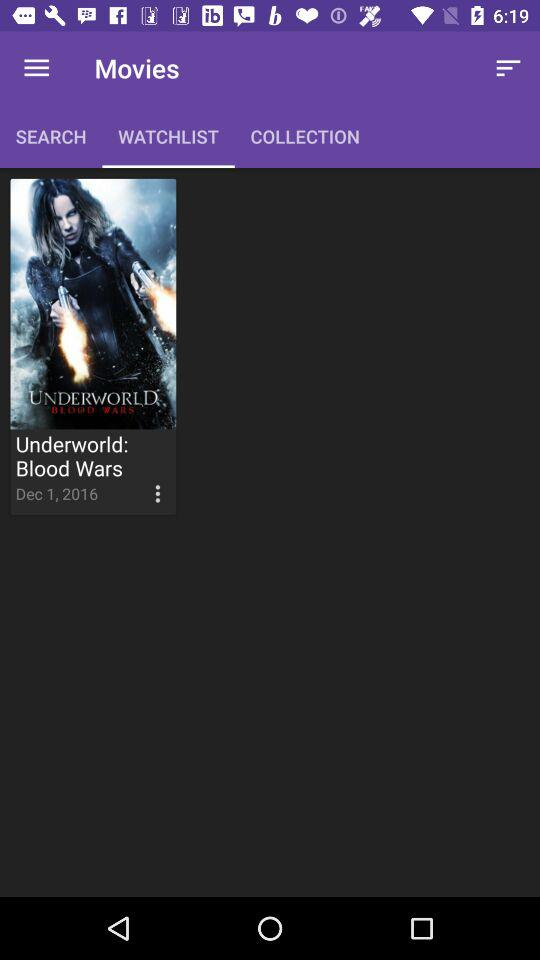Which tab am I on? You are on the "WATCHLIST" tab. 